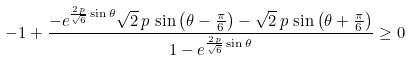<formula> <loc_0><loc_0><loc_500><loc_500>- 1 + \frac { - e ^ { \frac { 2 \, p } { \sqrt { 6 } } \sin \theta } \sqrt { 2 } \, p \, \sin \left ( \theta - \frac { \pi } { 6 } \right ) - \sqrt { 2 } \, p \, \sin \left ( \theta + \frac { \pi } { 6 } \right ) } { 1 - e ^ { \frac { 2 \, p } { \sqrt { 6 } } \sin \theta } } \geq 0</formula> 